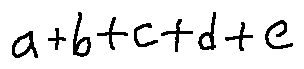<formula> <loc_0><loc_0><loc_500><loc_500>a + b + c + d + e</formula> 